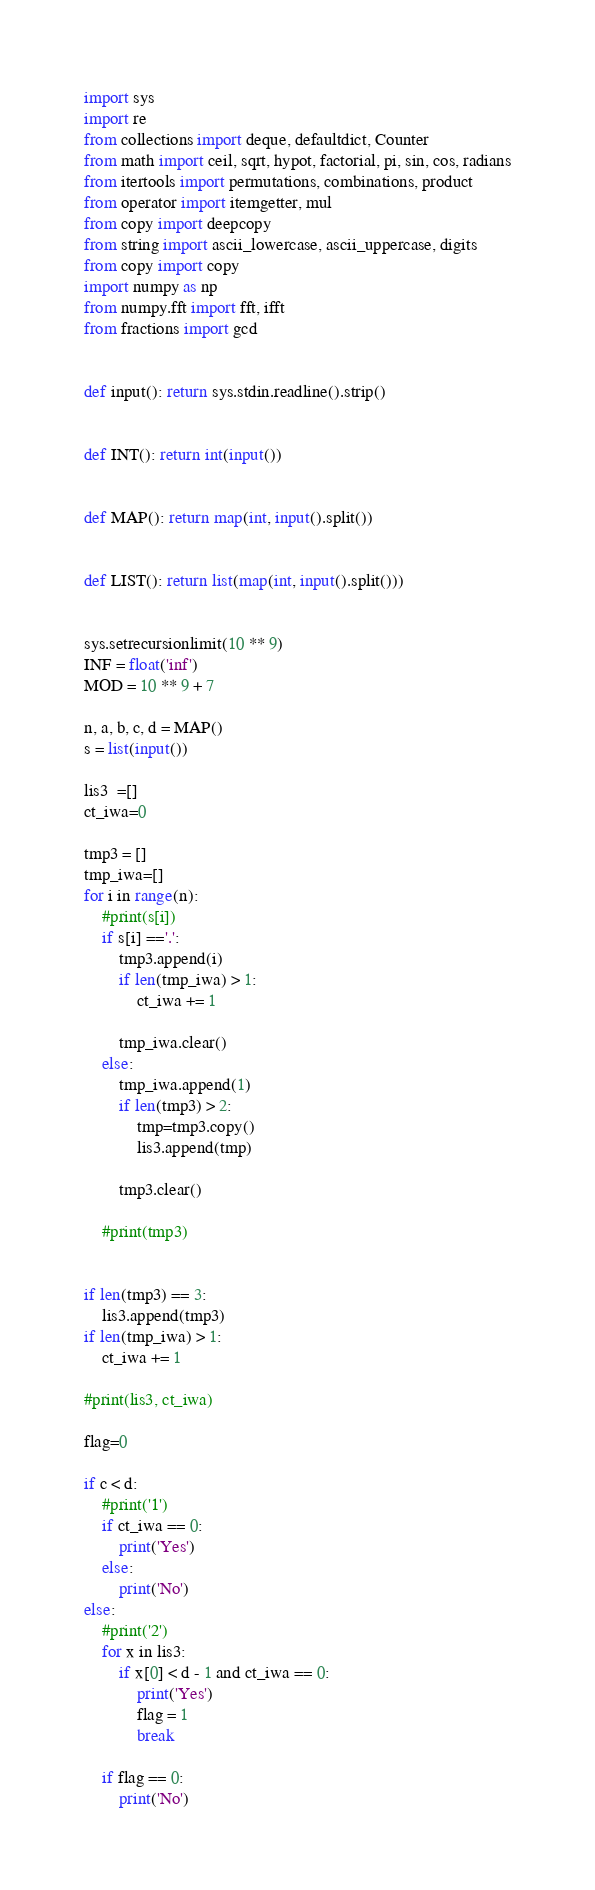Convert code to text. <code><loc_0><loc_0><loc_500><loc_500><_Python_>import sys
import re
from collections import deque, defaultdict, Counter
from math import ceil, sqrt, hypot, factorial, pi, sin, cos, radians
from itertools import permutations, combinations, product
from operator import itemgetter, mul
from copy import deepcopy
from string import ascii_lowercase, ascii_uppercase, digits
from copy import copy
import numpy as np
from numpy.fft import fft, ifft
from fractions import gcd


def input(): return sys.stdin.readline().strip()


def INT(): return int(input())


def MAP(): return map(int, input().split())


def LIST(): return list(map(int, input().split()))


sys.setrecursionlimit(10 ** 9)
INF = float('inf')
MOD = 10 ** 9 + 7

n, a, b, c, d = MAP()
s = list(input())

lis3  =[]
ct_iwa=0

tmp3 = []
tmp_iwa=[]
for i in range(n):
    #print(s[i])
    if s[i] =='.':
        tmp3.append(i)
        if len(tmp_iwa) > 1:
            ct_iwa += 1
            
        tmp_iwa.clear()
    else:
        tmp_iwa.append(1)
        if len(tmp3) > 2:
            tmp=tmp3.copy()
            lis3.append(tmp)
               
        tmp3.clear()
    
    #print(tmp3)


if len(tmp3) == 3:
    lis3.append(tmp3)
if len(tmp_iwa) > 1:
    ct_iwa += 1

#print(lis3, ct_iwa)

flag=0

if c < d:
    #print('1')
    if ct_iwa == 0:
        print('Yes')
    else:
        print('No')
else:
    #print('2')
    for x in lis3:
        if x[0] < d - 1 and ct_iwa == 0:
            print('Yes')
            flag = 1
            break

    if flag == 0:
        print('No')

</code> 